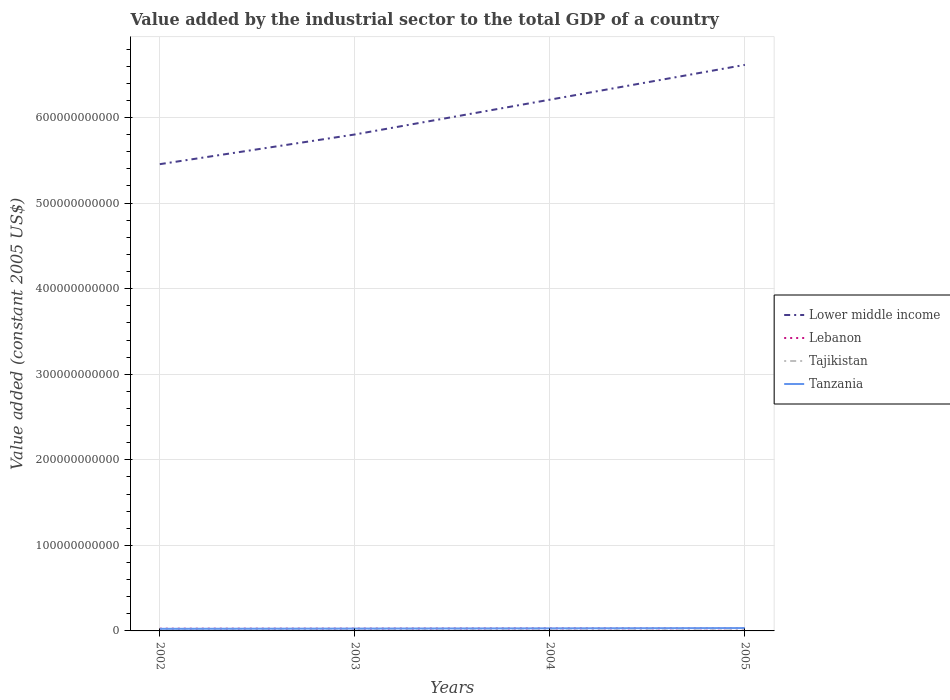Across all years, what is the maximum value added by the industrial sector in Lower middle income?
Offer a terse response. 5.46e+11. In which year was the value added by the industrial sector in Lebanon maximum?
Your answer should be very brief. 2002. What is the total value added by the industrial sector in Lebanon in the graph?
Ensure brevity in your answer.  -3.74e+08. What is the difference between the highest and the second highest value added by the industrial sector in Tanzania?
Offer a very short reply. 8.99e+08. Is the value added by the industrial sector in Lower middle income strictly greater than the value added by the industrial sector in Lebanon over the years?
Ensure brevity in your answer.  No. How many years are there in the graph?
Make the answer very short. 4. What is the difference between two consecutive major ticks on the Y-axis?
Give a very brief answer. 1.00e+11. Does the graph contain any zero values?
Keep it short and to the point. No. Does the graph contain grids?
Keep it short and to the point. Yes. Where does the legend appear in the graph?
Your answer should be very brief. Center right. How many legend labels are there?
Give a very brief answer. 4. What is the title of the graph?
Provide a short and direct response. Value added by the industrial sector to the total GDP of a country. What is the label or title of the Y-axis?
Keep it short and to the point. Value added (constant 2005 US$). What is the Value added (constant 2005 US$) of Lower middle income in 2002?
Keep it short and to the point. 5.46e+11. What is the Value added (constant 2005 US$) of Lebanon in 2002?
Provide a short and direct response. 2.60e+09. What is the Value added (constant 2005 US$) of Tajikistan in 2002?
Ensure brevity in your answer.  5.33e+08. What is the Value added (constant 2005 US$) in Tanzania in 2002?
Offer a very short reply. 2.44e+09. What is the Value added (constant 2005 US$) of Lower middle income in 2003?
Provide a short and direct response. 5.80e+11. What is the Value added (constant 2005 US$) in Lebanon in 2003?
Make the answer very short. 2.69e+09. What is the Value added (constant 2005 US$) of Tajikistan in 2003?
Your response must be concise. 5.83e+08. What is the Value added (constant 2005 US$) in Tanzania in 2003?
Give a very brief answer. 2.71e+09. What is the Value added (constant 2005 US$) in Lower middle income in 2004?
Keep it short and to the point. 6.21e+11. What is the Value added (constant 2005 US$) of Lebanon in 2004?
Offer a terse response. 2.92e+09. What is the Value added (constant 2005 US$) of Tajikistan in 2004?
Your response must be concise. 5.99e+08. What is the Value added (constant 2005 US$) in Tanzania in 2004?
Keep it short and to the point. 3.01e+09. What is the Value added (constant 2005 US$) of Lower middle income in 2005?
Your answer should be very brief. 6.62e+11. What is the Value added (constant 2005 US$) in Lebanon in 2005?
Make the answer very short. 3.06e+09. What is the Value added (constant 2005 US$) of Tajikistan in 2005?
Your answer should be very brief. 6.40e+08. What is the Value added (constant 2005 US$) in Tanzania in 2005?
Offer a very short reply. 3.34e+09. Across all years, what is the maximum Value added (constant 2005 US$) of Lower middle income?
Your answer should be very brief. 6.62e+11. Across all years, what is the maximum Value added (constant 2005 US$) in Lebanon?
Ensure brevity in your answer.  3.06e+09. Across all years, what is the maximum Value added (constant 2005 US$) in Tajikistan?
Provide a succinct answer. 6.40e+08. Across all years, what is the maximum Value added (constant 2005 US$) in Tanzania?
Your answer should be very brief. 3.34e+09. Across all years, what is the minimum Value added (constant 2005 US$) in Lower middle income?
Your answer should be very brief. 5.46e+11. Across all years, what is the minimum Value added (constant 2005 US$) of Lebanon?
Keep it short and to the point. 2.60e+09. Across all years, what is the minimum Value added (constant 2005 US$) of Tajikistan?
Give a very brief answer. 5.33e+08. Across all years, what is the minimum Value added (constant 2005 US$) in Tanzania?
Your answer should be compact. 2.44e+09. What is the total Value added (constant 2005 US$) of Lower middle income in the graph?
Offer a very short reply. 2.41e+12. What is the total Value added (constant 2005 US$) in Lebanon in the graph?
Your answer should be compact. 1.13e+1. What is the total Value added (constant 2005 US$) in Tajikistan in the graph?
Keep it short and to the point. 2.35e+09. What is the total Value added (constant 2005 US$) of Tanzania in the graph?
Give a very brief answer. 1.15e+1. What is the difference between the Value added (constant 2005 US$) of Lower middle income in 2002 and that in 2003?
Ensure brevity in your answer.  -3.47e+1. What is the difference between the Value added (constant 2005 US$) of Lebanon in 2002 and that in 2003?
Provide a short and direct response. -8.68e+07. What is the difference between the Value added (constant 2005 US$) in Tajikistan in 2002 and that in 2003?
Provide a succinct answer. -4.97e+07. What is the difference between the Value added (constant 2005 US$) of Tanzania in 2002 and that in 2003?
Keep it short and to the point. -2.67e+08. What is the difference between the Value added (constant 2005 US$) in Lower middle income in 2002 and that in 2004?
Make the answer very short. -7.54e+1. What is the difference between the Value added (constant 2005 US$) in Lebanon in 2002 and that in 2004?
Your response must be concise. -3.14e+08. What is the difference between the Value added (constant 2005 US$) of Tajikistan in 2002 and that in 2004?
Make the answer very short. -6.61e+07. What is the difference between the Value added (constant 2005 US$) in Tanzania in 2002 and that in 2004?
Offer a very short reply. -5.63e+08. What is the difference between the Value added (constant 2005 US$) in Lower middle income in 2002 and that in 2005?
Give a very brief answer. -1.16e+11. What is the difference between the Value added (constant 2005 US$) of Lebanon in 2002 and that in 2005?
Give a very brief answer. -4.61e+08. What is the difference between the Value added (constant 2005 US$) of Tajikistan in 2002 and that in 2005?
Offer a terse response. -1.07e+08. What is the difference between the Value added (constant 2005 US$) of Tanzania in 2002 and that in 2005?
Give a very brief answer. -8.99e+08. What is the difference between the Value added (constant 2005 US$) in Lower middle income in 2003 and that in 2004?
Ensure brevity in your answer.  -4.07e+1. What is the difference between the Value added (constant 2005 US$) of Lebanon in 2003 and that in 2004?
Offer a terse response. -2.28e+08. What is the difference between the Value added (constant 2005 US$) of Tajikistan in 2003 and that in 2004?
Ensure brevity in your answer.  -1.63e+07. What is the difference between the Value added (constant 2005 US$) in Tanzania in 2003 and that in 2004?
Your answer should be very brief. -2.95e+08. What is the difference between the Value added (constant 2005 US$) in Lower middle income in 2003 and that in 2005?
Make the answer very short. -8.14e+1. What is the difference between the Value added (constant 2005 US$) in Lebanon in 2003 and that in 2005?
Your answer should be compact. -3.74e+08. What is the difference between the Value added (constant 2005 US$) of Tajikistan in 2003 and that in 2005?
Your response must be concise. -5.69e+07. What is the difference between the Value added (constant 2005 US$) of Tanzania in 2003 and that in 2005?
Provide a succinct answer. -6.31e+08. What is the difference between the Value added (constant 2005 US$) of Lower middle income in 2004 and that in 2005?
Keep it short and to the point. -4.07e+1. What is the difference between the Value added (constant 2005 US$) of Lebanon in 2004 and that in 2005?
Provide a succinct answer. -1.46e+08. What is the difference between the Value added (constant 2005 US$) in Tajikistan in 2004 and that in 2005?
Ensure brevity in your answer.  -4.06e+07. What is the difference between the Value added (constant 2005 US$) of Tanzania in 2004 and that in 2005?
Make the answer very short. -3.36e+08. What is the difference between the Value added (constant 2005 US$) in Lower middle income in 2002 and the Value added (constant 2005 US$) in Lebanon in 2003?
Provide a succinct answer. 5.43e+11. What is the difference between the Value added (constant 2005 US$) of Lower middle income in 2002 and the Value added (constant 2005 US$) of Tajikistan in 2003?
Offer a terse response. 5.45e+11. What is the difference between the Value added (constant 2005 US$) of Lower middle income in 2002 and the Value added (constant 2005 US$) of Tanzania in 2003?
Ensure brevity in your answer.  5.43e+11. What is the difference between the Value added (constant 2005 US$) of Lebanon in 2002 and the Value added (constant 2005 US$) of Tajikistan in 2003?
Keep it short and to the point. 2.02e+09. What is the difference between the Value added (constant 2005 US$) in Lebanon in 2002 and the Value added (constant 2005 US$) in Tanzania in 2003?
Your response must be concise. -1.10e+08. What is the difference between the Value added (constant 2005 US$) of Tajikistan in 2002 and the Value added (constant 2005 US$) of Tanzania in 2003?
Provide a short and direct response. -2.18e+09. What is the difference between the Value added (constant 2005 US$) in Lower middle income in 2002 and the Value added (constant 2005 US$) in Lebanon in 2004?
Your response must be concise. 5.43e+11. What is the difference between the Value added (constant 2005 US$) of Lower middle income in 2002 and the Value added (constant 2005 US$) of Tajikistan in 2004?
Keep it short and to the point. 5.45e+11. What is the difference between the Value added (constant 2005 US$) of Lower middle income in 2002 and the Value added (constant 2005 US$) of Tanzania in 2004?
Offer a terse response. 5.43e+11. What is the difference between the Value added (constant 2005 US$) in Lebanon in 2002 and the Value added (constant 2005 US$) in Tajikistan in 2004?
Offer a very short reply. 2.00e+09. What is the difference between the Value added (constant 2005 US$) of Lebanon in 2002 and the Value added (constant 2005 US$) of Tanzania in 2004?
Your answer should be very brief. -4.05e+08. What is the difference between the Value added (constant 2005 US$) of Tajikistan in 2002 and the Value added (constant 2005 US$) of Tanzania in 2004?
Your response must be concise. -2.47e+09. What is the difference between the Value added (constant 2005 US$) in Lower middle income in 2002 and the Value added (constant 2005 US$) in Lebanon in 2005?
Your answer should be compact. 5.42e+11. What is the difference between the Value added (constant 2005 US$) in Lower middle income in 2002 and the Value added (constant 2005 US$) in Tajikistan in 2005?
Your answer should be very brief. 5.45e+11. What is the difference between the Value added (constant 2005 US$) of Lower middle income in 2002 and the Value added (constant 2005 US$) of Tanzania in 2005?
Ensure brevity in your answer.  5.42e+11. What is the difference between the Value added (constant 2005 US$) in Lebanon in 2002 and the Value added (constant 2005 US$) in Tajikistan in 2005?
Make the answer very short. 1.96e+09. What is the difference between the Value added (constant 2005 US$) in Lebanon in 2002 and the Value added (constant 2005 US$) in Tanzania in 2005?
Offer a terse response. -7.41e+08. What is the difference between the Value added (constant 2005 US$) in Tajikistan in 2002 and the Value added (constant 2005 US$) in Tanzania in 2005?
Make the answer very short. -2.81e+09. What is the difference between the Value added (constant 2005 US$) of Lower middle income in 2003 and the Value added (constant 2005 US$) of Lebanon in 2004?
Keep it short and to the point. 5.77e+11. What is the difference between the Value added (constant 2005 US$) of Lower middle income in 2003 and the Value added (constant 2005 US$) of Tajikistan in 2004?
Offer a terse response. 5.80e+11. What is the difference between the Value added (constant 2005 US$) in Lower middle income in 2003 and the Value added (constant 2005 US$) in Tanzania in 2004?
Keep it short and to the point. 5.77e+11. What is the difference between the Value added (constant 2005 US$) of Lebanon in 2003 and the Value added (constant 2005 US$) of Tajikistan in 2004?
Provide a short and direct response. 2.09e+09. What is the difference between the Value added (constant 2005 US$) of Lebanon in 2003 and the Value added (constant 2005 US$) of Tanzania in 2004?
Make the answer very short. -3.18e+08. What is the difference between the Value added (constant 2005 US$) in Tajikistan in 2003 and the Value added (constant 2005 US$) in Tanzania in 2004?
Your answer should be very brief. -2.42e+09. What is the difference between the Value added (constant 2005 US$) of Lower middle income in 2003 and the Value added (constant 2005 US$) of Lebanon in 2005?
Provide a short and direct response. 5.77e+11. What is the difference between the Value added (constant 2005 US$) in Lower middle income in 2003 and the Value added (constant 2005 US$) in Tajikistan in 2005?
Give a very brief answer. 5.80e+11. What is the difference between the Value added (constant 2005 US$) of Lower middle income in 2003 and the Value added (constant 2005 US$) of Tanzania in 2005?
Offer a terse response. 5.77e+11. What is the difference between the Value added (constant 2005 US$) in Lebanon in 2003 and the Value added (constant 2005 US$) in Tajikistan in 2005?
Keep it short and to the point. 2.05e+09. What is the difference between the Value added (constant 2005 US$) in Lebanon in 2003 and the Value added (constant 2005 US$) in Tanzania in 2005?
Your response must be concise. -6.54e+08. What is the difference between the Value added (constant 2005 US$) of Tajikistan in 2003 and the Value added (constant 2005 US$) of Tanzania in 2005?
Your response must be concise. -2.76e+09. What is the difference between the Value added (constant 2005 US$) in Lower middle income in 2004 and the Value added (constant 2005 US$) in Lebanon in 2005?
Ensure brevity in your answer.  6.18e+11. What is the difference between the Value added (constant 2005 US$) in Lower middle income in 2004 and the Value added (constant 2005 US$) in Tajikistan in 2005?
Your answer should be very brief. 6.20e+11. What is the difference between the Value added (constant 2005 US$) of Lower middle income in 2004 and the Value added (constant 2005 US$) of Tanzania in 2005?
Your answer should be compact. 6.18e+11. What is the difference between the Value added (constant 2005 US$) of Lebanon in 2004 and the Value added (constant 2005 US$) of Tajikistan in 2005?
Provide a succinct answer. 2.28e+09. What is the difference between the Value added (constant 2005 US$) in Lebanon in 2004 and the Value added (constant 2005 US$) in Tanzania in 2005?
Provide a succinct answer. -4.27e+08. What is the difference between the Value added (constant 2005 US$) of Tajikistan in 2004 and the Value added (constant 2005 US$) of Tanzania in 2005?
Your answer should be very brief. -2.74e+09. What is the average Value added (constant 2005 US$) in Lower middle income per year?
Keep it short and to the point. 6.02e+11. What is the average Value added (constant 2005 US$) of Lebanon per year?
Ensure brevity in your answer.  2.82e+09. What is the average Value added (constant 2005 US$) in Tajikistan per year?
Offer a very short reply. 5.88e+08. What is the average Value added (constant 2005 US$) of Tanzania per year?
Give a very brief answer. 2.88e+09. In the year 2002, what is the difference between the Value added (constant 2005 US$) of Lower middle income and Value added (constant 2005 US$) of Lebanon?
Provide a short and direct response. 5.43e+11. In the year 2002, what is the difference between the Value added (constant 2005 US$) of Lower middle income and Value added (constant 2005 US$) of Tajikistan?
Your response must be concise. 5.45e+11. In the year 2002, what is the difference between the Value added (constant 2005 US$) of Lower middle income and Value added (constant 2005 US$) of Tanzania?
Provide a succinct answer. 5.43e+11. In the year 2002, what is the difference between the Value added (constant 2005 US$) in Lebanon and Value added (constant 2005 US$) in Tajikistan?
Make the answer very short. 2.07e+09. In the year 2002, what is the difference between the Value added (constant 2005 US$) of Lebanon and Value added (constant 2005 US$) of Tanzania?
Your answer should be compact. 1.58e+08. In the year 2002, what is the difference between the Value added (constant 2005 US$) of Tajikistan and Value added (constant 2005 US$) of Tanzania?
Make the answer very short. -1.91e+09. In the year 2003, what is the difference between the Value added (constant 2005 US$) in Lower middle income and Value added (constant 2005 US$) in Lebanon?
Your answer should be very brief. 5.78e+11. In the year 2003, what is the difference between the Value added (constant 2005 US$) in Lower middle income and Value added (constant 2005 US$) in Tajikistan?
Your answer should be very brief. 5.80e+11. In the year 2003, what is the difference between the Value added (constant 2005 US$) of Lower middle income and Value added (constant 2005 US$) of Tanzania?
Your response must be concise. 5.78e+11. In the year 2003, what is the difference between the Value added (constant 2005 US$) of Lebanon and Value added (constant 2005 US$) of Tajikistan?
Make the answer very short. 2.11e+09. In the year 2003, what is the difference between the Value added (constant 2005 US$) in Lebanon and Value added (constant 2005 US$) in Tanzania?
Offer a very short reply. -2.29e+07. In the year 2003, what is the difference between the Value added (constant 2005 US$) in Tajikistan and Value added (constant 2005 US$) in Tanzania?
Provide a short and direct response. -2.13e+09. In the year 2004, what is the difference between the Value added (constant 2005 US$) in Lower middle income and Value added (constant 2005 US$) in Lebanon?
Ensure brevity in your answer.  6.18e+11. In the year 2004, what is the difference between the Value added (constant 2005 US$) of Lower middle income and Value added (constant 2005 US$) of Tajikistan?
Your answer should be very brief. 6.20e+11. In the year 2004, what is the difference between the Value added (constant 2005 US$) in Lower middle income and Value added (constant 2005 US$) in Tanzania?
Ensure brevity in your answer.  6.18e+11. In the year 2004, what is the difference between the Value added (constant 2005 US$) of Lebanon and Value added (constant 2005 US$) of Tajikistan?
Offer a terse response. 2.32e+09. In the year 2004, what is the difference between the Value added (constant 2005 US$) of Lebanon and Value added (constant 2005 US$) of Tanzania?
Make the answer very short. -9.06e+07. In the year 2004, what is the difference between the Value added (constant 2005 US$) of Tajikistan and Value added (constant 2005 US$) of Tanzania?
Your answer should be compact. -2.41e+09. In the year 2005, what is the difference between the Value added (constant 2005 US$) in Lower middle income and Value added (constant 2005 US$) in Lebanon?
Give a very brief answer. 6.59e+11. In the year 2005, what is the difference between the Value added (constant 2005 US$) of Lower middle income and Value added (constant 2005 US$) of Tajikistan?
Your answer should be very brief. 6.61e+11. In the year 2005, what is the difference between the Value added (constant 2005 US$) in Lower middle income and Value added (constant 2005 US$) in Tanzania?
Your response must be concise. 6.58e+11. In the year 2005, what is the difference between the Value added (constant 2005 US$) of Lebanon and Value added (constant 2005 US$) of Tajikistan?
Your answer should be very brief. 2.42e+09. In the year 2005, what is the difference between the Value added (constant 2005 US$) in Lebanon and Value added (constant 2005 US$) in Tanzania?
Your answer should be very brief. -2.80e+08. In the year 2005, what is the difference between the Value added (constant 2005 US$) in Tajikistan and Value added (constant 2005 US$) in Tanzania?
Offer a terse response. -2.70e+09. What is the ratio of the Value added (constant 2005 US$) of Lower middle income in 2002 to that in 2003?
Your response must be concise. 0.94. What is the ratio of the Value added (constant 2005 US$) of Lebanon in 2002 to that in 2003?
Offer a very short reply. 0.97. What is the ratio of the Value added (constant 2005 US$) of Tajikistan in 2002 to that in 2003?
Ensure brevity in your answer.  0.91. What is the ratio of the Value added (constant 2005 US$) in Tanzania in 2002 to that in 2003?
Provide a short and direct response. 0.9. What is the ratio of the Value added (constant 2005 US$) of Lower middle income in 2002 to that in 2004?
Make the answer very short. 0.88. What is the ratio of the Value added (constant 2005 US$) in Lebanon in 2002 to that in 2004?
Provide a short and direct response. 0.89. What is the ratio of the Value added (constant 2005 US$) of Tajikistan in 2002 to that in 2004?
Keep it short and to the point. 0.89. What is the ratio of the Value added (constant 2005 US$) in Tanzania in 2002 to that in 2004?
Make the answer very short. 0.81. What is the ratio of the Value added (constant 2005 US$) in Lower middle income in 2002 to that in 2005?
Your answer should be very brief. 0.82. What is the ratio of the Value added (constant 2005 US$) in Lebanon in 2002 to that in 2005?
Your answer should be very brief. 0.85. What is the ratio of the Value added (constant 2005 US$) in Tajikistan in 2002 to that in 2005?
Provide a short and direct response. 0.83. What is the ratio of the Value added (constant 2005 US$) in Tanzania in 2002 to that in 2005?
Offer a terse response. 0.73. What is the ratio of the Value added (constant 2005 US$) in Lower middle income in 2003 to that in 2004?
Give a very brief answer. 0.93. What is the ratio of the Value added (constant 2005 US$) in Lebanon in 2003 to that in 2004?
Keep it short and to the point. 0.92. What is the ratio of the Value added (constant 2005 US$) in Tajikistan in 2003 to that in 2004?
Your answer should be very brief. 0.97. What is the ratio of the Value added (constant 2005 US$) in Tanzania in 2003 to that in 2004?
Make the answer very short. 0.9. What is the ratio of the Value added (constant 2005 US$) in Lower middle income in 2003 to that in 2005?
Provide a short and direct response. 0.88. What is the ratio of the Value added (constant 2005 US$) of Lebanon in 2003 to that in 2005?
Your answer should be compact. 0.88. What is the ratio of the Value added (constant 2005 US$) of Tajikistan in 2003 to that in 2005?
Make the answer very short. 0.91. What is the ratio of the Value added (constant 2005 US$) in Tanzania in 2003 to that in 2005?
Give a very brief answer. 0.81. What is the ratio of the Value added (constant 2005 US$) in Lower middle income in 2004 to that in 2005?
Keep it short and to the point. 0.94. What is the ratio of the Value added (constant 2005 US$) of Lebanon in 2004 to that in 2005?
Provide a succinct answer. 0.95. What is the ratio of the Value added (constant 2005 US$) of Tajikistan in 2004 to that in 2005?
Your answer should be very brief. 0.94. What is the ratio of the Value added (constant 2005 US$) in Tanzania in 2004 to that in 2005?
Make the answer very short. 0.9. What is the difference between the highest and the second highest Value added (constant 2005 US$) of Lower middle income?
Keep it short and to the point. 4.07e+1. What is the difference between the highest and the second highest Value added (constant 2005 US$) of Lebanon?
Offer a terse response. 1.46e+08. What is the difference between the highest and the second highest Value added (constant 2005 US$) of Tajikistan?
Provide a succinct answer. 4.06e+07. What is the difference between the highest and the second highest Value added (constant 2005 US$) in Tanzania?
Ensure brevity in your answer.  3.36e+08. What is the difference between the highest and the lowest Value added (constant 2005 US$) of Lower middle income?
Your answer should be compact. 1.16e+11. What is the difference between the highest and the lowest Value added (constant 2005 US$) of Lebanon?
Offer a terse response. 4.61e+08. What is the difference between the highest and the lowest Value added (constant 2005 US$) of Tajikistan?
Provide a succinct answer. 1.07e+08. What is the difference between the highest and the lowest Value added (constant 2005 US$) in Tanzania?
Provide a short and direct response. 8.99e+08. 